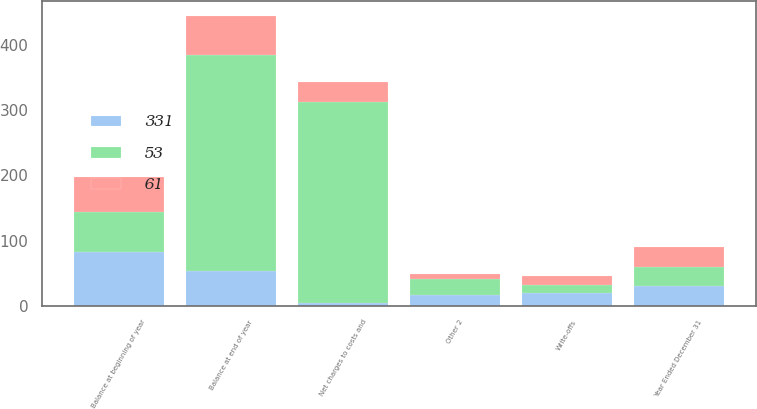Convert chart. <chart><loc_0><loc_0><loc_500><loc_500><stacked_bar_chart><ecel><fcel>Year Ended December 31<fcel>Balance at beginning of year<fcel>Net charges to costs and<fcel>Write-offs<fcel>Other 2<fcel>Balance at end of year<nl><fcel>53<fcel>30<fcel>61<fcel>308<fcel>13<fcel>25<fcel>331<nl><fcel>61<fcel>30<fcel>53<fcel>30<fcel>14<fcel>8<fcel>61<nl><fcel>331<fcel>30<fcel>83<fcel>5<fcel>19<fcel>16<fcel>53<nl></chart> 